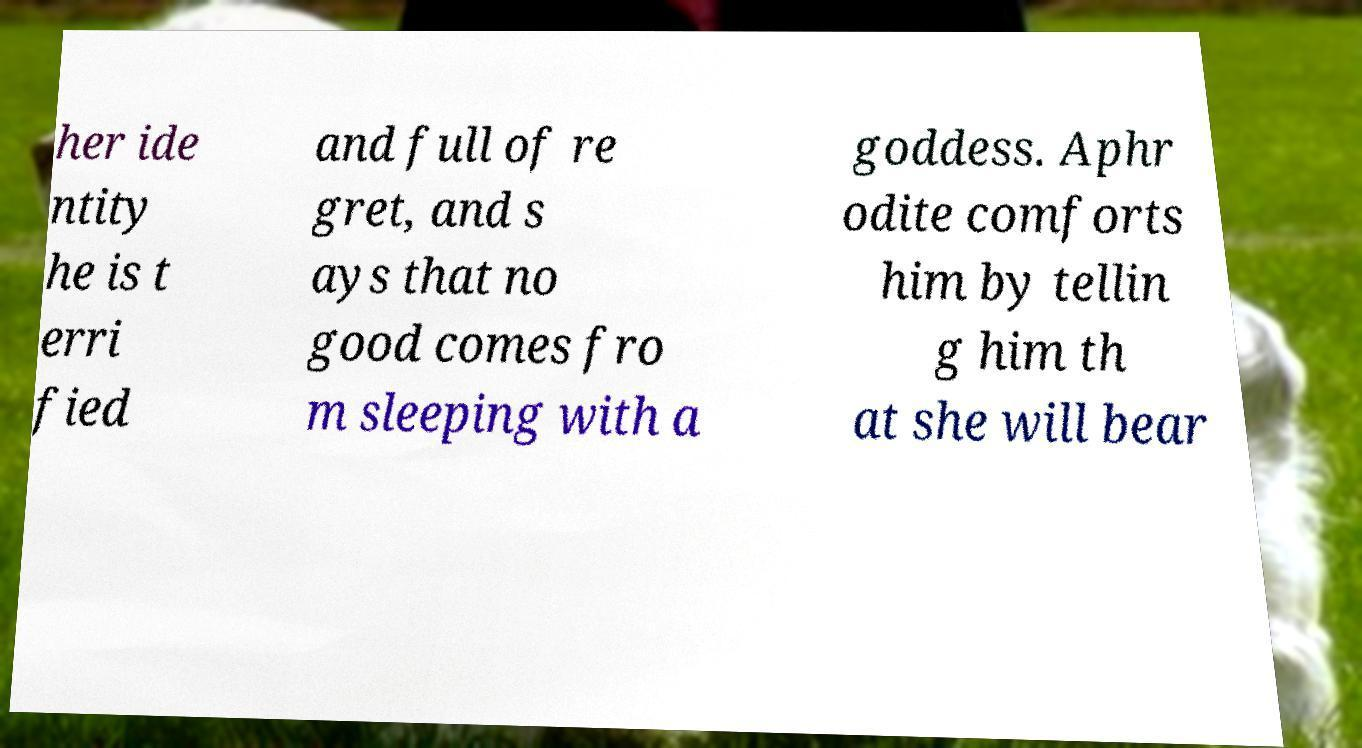Please read and relay the text visible in this image. What does it say? her ide ntity he is t erri fied and full of re gret, and s ays that no good comes fro m sleeping with a goddess. Aphr odite comforts him by tellin g him th at she will bear 